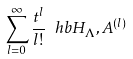Convert formula to latex. <formula><loc_0><loc_0><loc_500><loc_500>\sum _ { l = 0 } ^ { \infty } \frac { t ^ { l } } { l ! } \ h b { H _ { \Lambda } , A } ^ { ( l ) }</formula> 